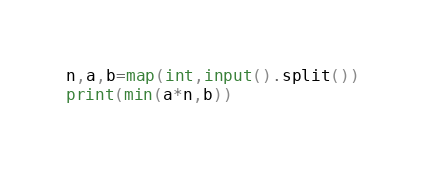Convert code to text. <code><loc_0><loc_0><loc_500><loc_500><_Python_>n,a,b=map(int,input().split())
print(min(a*n,b))</code> 